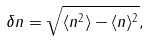<formula> <loc_0><loc_0><loc_500><loc_500>\delta n = \sqrt { \langle n ^ { 2 } \rangle - \langle n \rangle ^ { 2 } } ,</formula> 